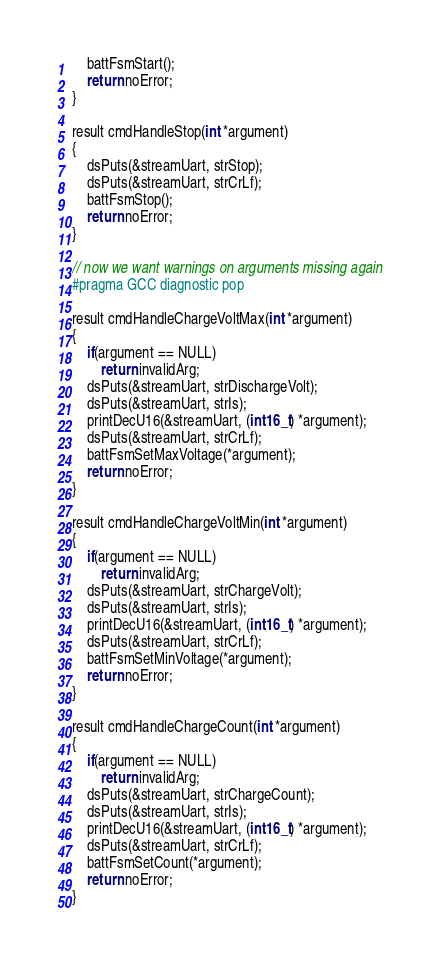Convert code to text. <code><loc_0><loc_0><loc_500><loc_500><_C++_>    battFsmStart();
    return noError;
}

result cmdHandleStop(int *argument)
{
    dsPuts(&streamUart, strStop);
    dsPuts(&streamUart, strCrLf);
    battFsmStop();
    return noError;
}

// now we want warnings on arguments missing again
#pragma GCC diagnostic pop

result cmdHandleChargeVoltMax(int *argument)
{
    if(argument == NULL)
        return invalidArg;
    dsPuts(&streamUart, strDischargeVolt);
    dsPuts(&streamUart, strIs);
    printDecU16(&streamUart, (int16_t) *argument);
    dsPuts(&streamUart, strCrLf);
    battFsmSetMaxVoltage(*argument);
    return noError;
}

result cmdHandleChargeVoltMin(int *argument)
{
    if(argument == NULL)
        return invalidArg;
    dsPuts(&streamUart, strChargeVolt);
    dsPuts(&streamUart, strIs);
    printDecU16(&streamUart, (int16_t) *argument);
    dsPuts(&streamUart, strCrLf);
    battFsmSetMinVoltage(*argument);
    return noError;
}

result cmdHandleChargeCount(int *argument)
{
    if(argument == NULL)
        return invalidArg;
    dsPuts(&streamUart, strChargeCount);
    dsPuts(&streamUart, strIs);
    printDecU16(&streamUart, (int16_t) *argument);
    dsPuts(&streamUart, strCrLf);
    battFsmSetCount(*argument);
    return noError;
}
</code> 